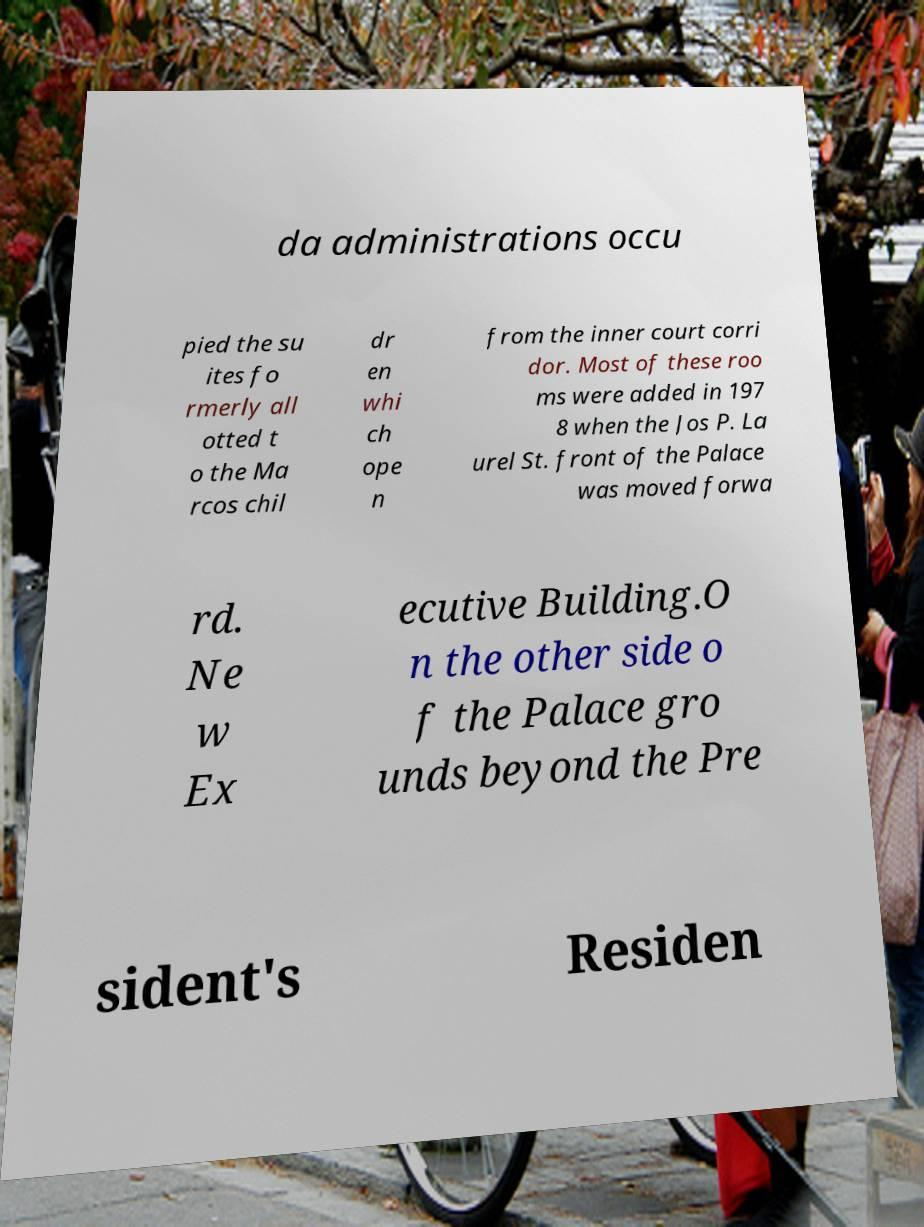Can you accurately transcribe the text from the provided image for me? da administrations occu pied the su ites fo rmerly all otted t o the Ma rcos chil dr en whi ch ope n from the inner court corri dor. Most of these roo ms were added in 197 8 when the Jos P. La urel St. front of the Palace was moved forwa rd. Ne w Ex ecutive Building.O n the other side o f the Palace gro unds beyond the Pre sident's Residen 